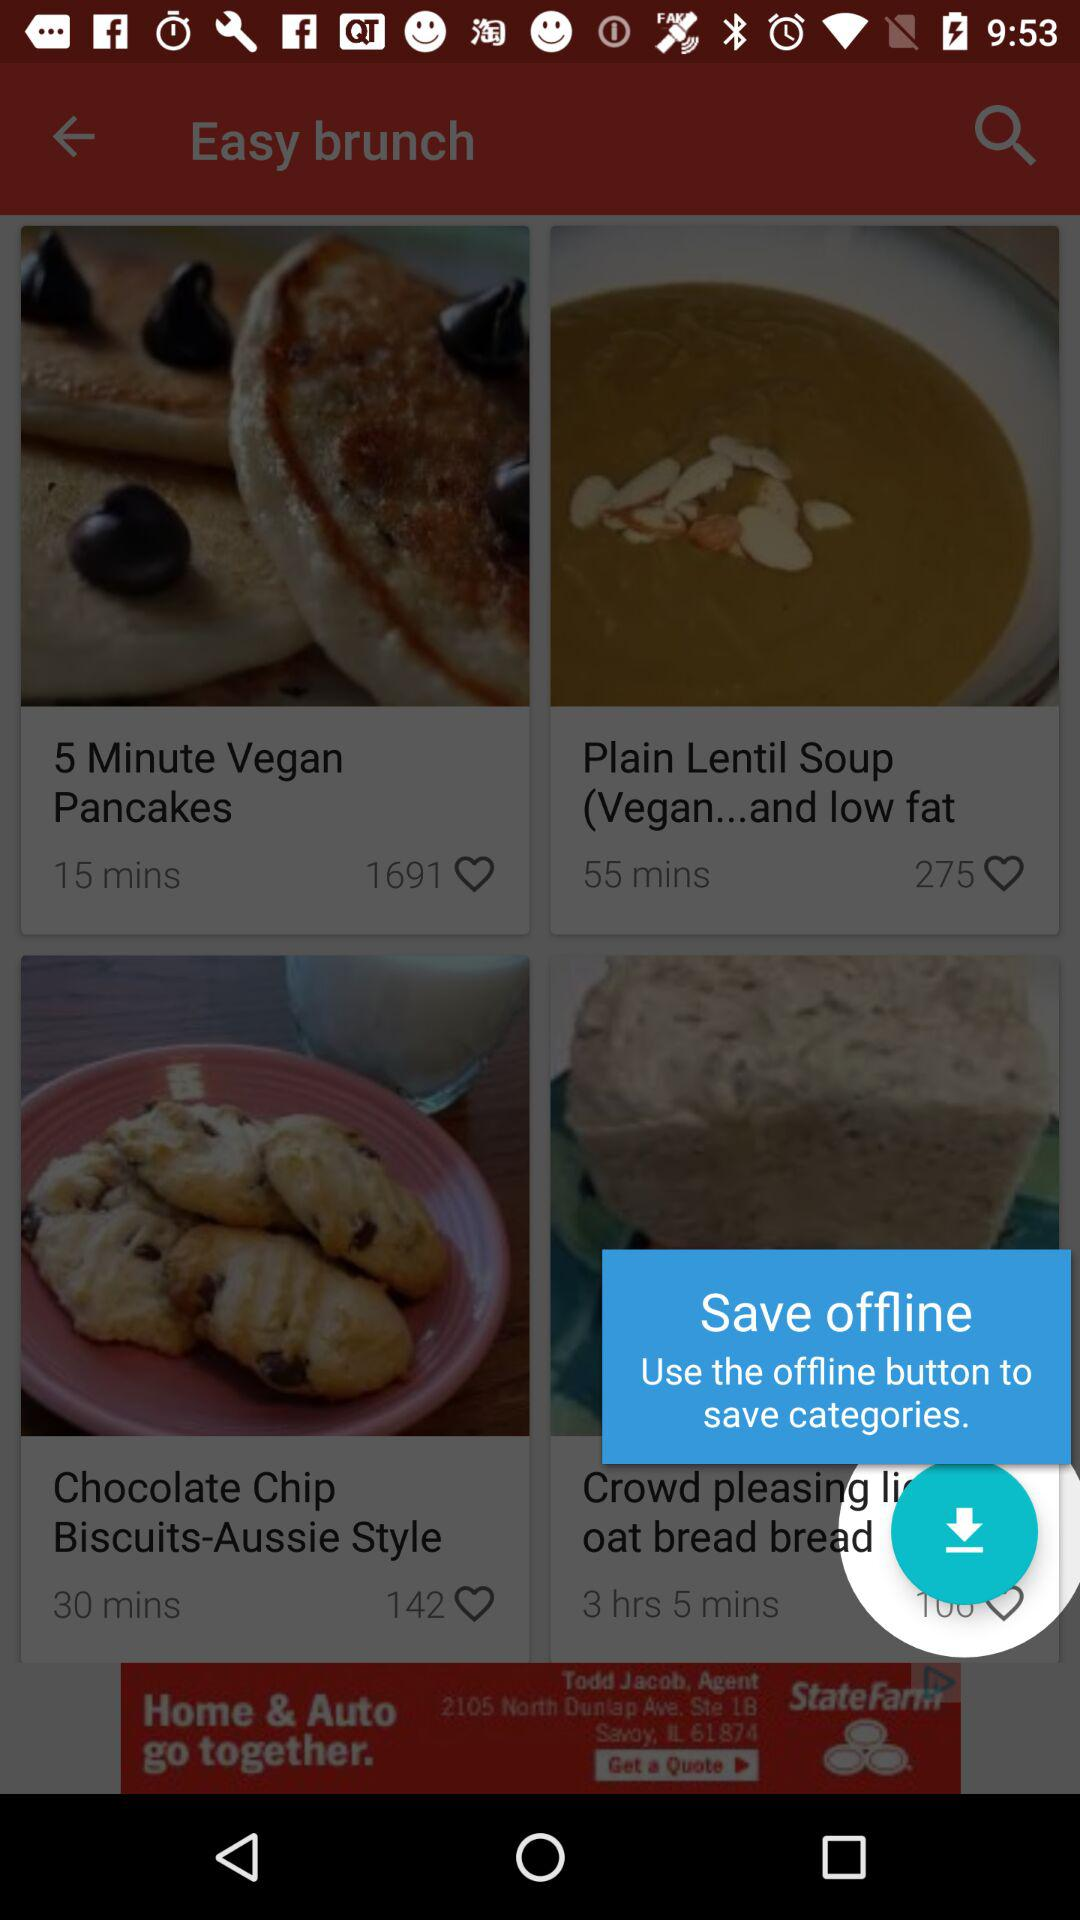How many minutes longer is the cooking time of the plain lentil soup than the 5 minute vegan pancakes?
Answer the question using a single word or phrase. 40 